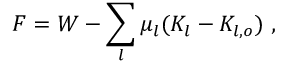Convert formula to latex. <formula><loc_0><loc_0><loc_500><loc_500>F = W - \sum _ { l } \mu _ { l } ( K _ { l } - K _ { l , o } ) \ ,</formula> 